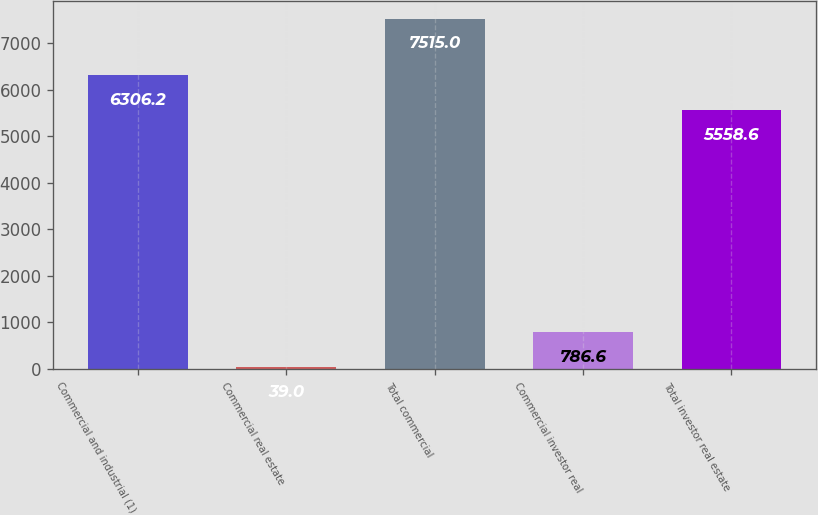<chart> <loc_0><loc_0><loc_500><loc_500><bar_chart><fcel>Commercial and industrial (1)<fcel>Commercial real estate<fcel>Total commercial<fcel>Commercial investor real<fcel>Total investor real estate<nl><fcel>6306.2<fcel>39<fcel>7515<fcel>786.6<fcel>5558.6<nl></chart> 